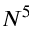Convert formula to latex. <formula><loc_0><loc_0><loc_500><loc_500>N ^ { 5 }</formula> 